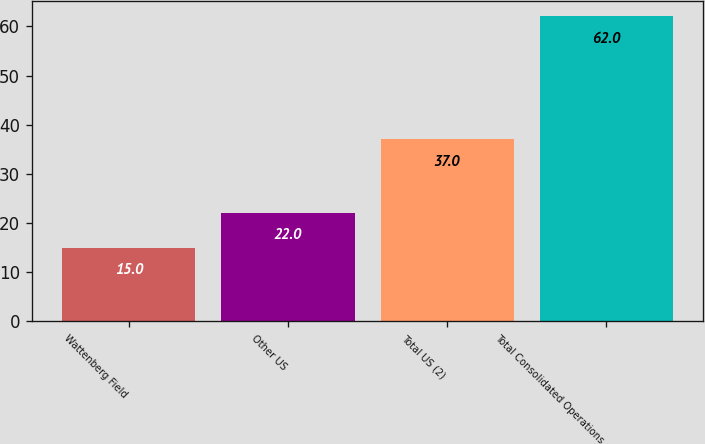<chart> <loc_0><loc_0><loc_500><loc_500><bar_chart><fcel>Wattenberg Field<fcel>Other US<fcel>Total US (2)<fcel>Total Consolidated Operations<nl><fcel>15<fcel>22<fcel>37<fcel>62<nl></chart> 